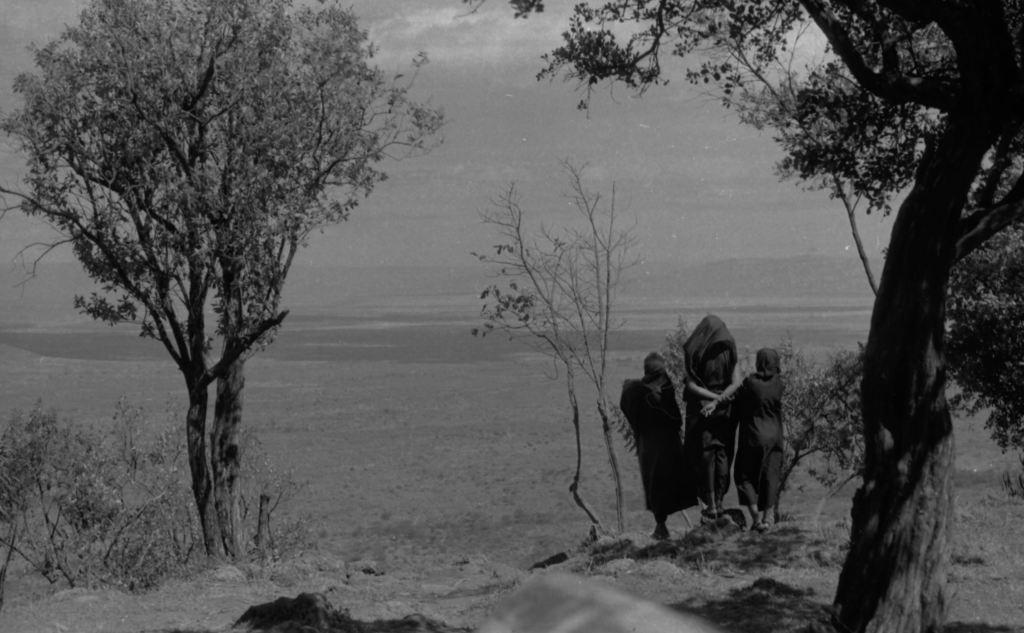How many people are in the image? There are three persons in the image. What can be seen in the background of the image? Trees and an open ground are visible in the background of the image. What is visible at the top of the image? The sky is visible in the background of the image. What type of education can be seen in the image? There is no indication of education in the image; it features three persons and a natural setting. Can you tell me how many apples are visible in the image? There are no apples present in the image. 